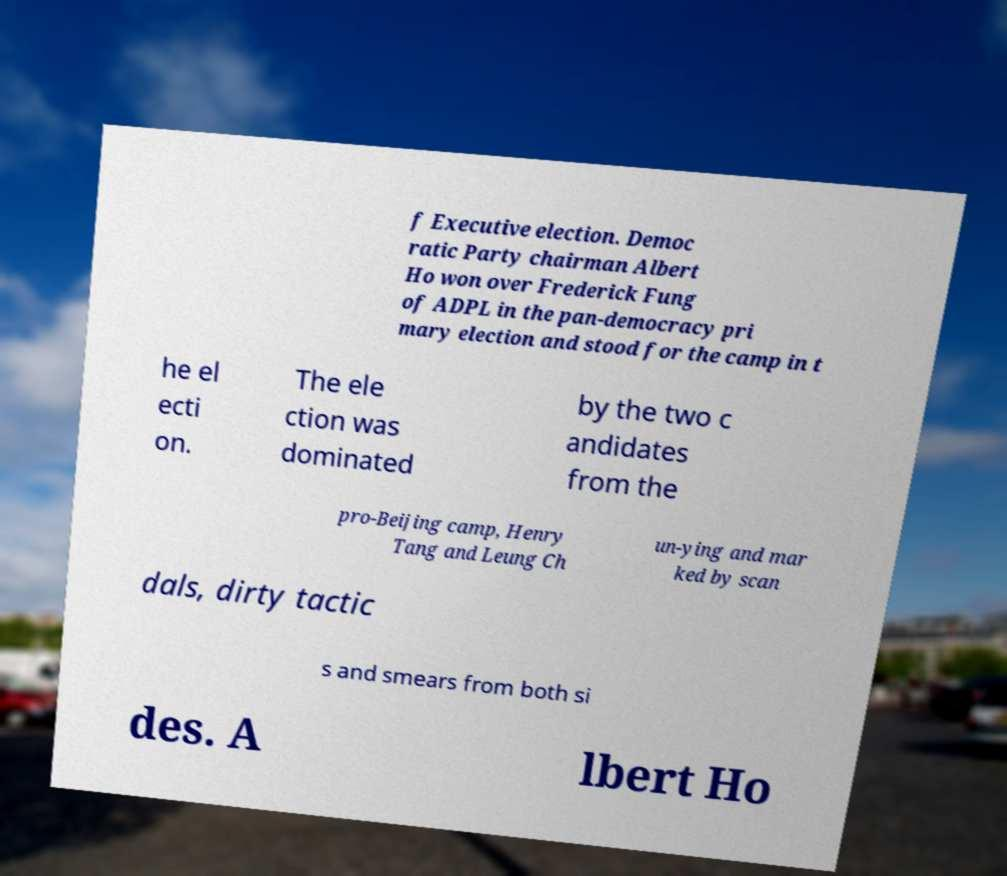Could you extract and type out the text from this image? f Executive election. Democ ratic Party chairman Albert Ho won over Frederick Fung of ADPL in the pan-democracy pri mary election and stood for the camp in t he el ecti on. The ele ction was dominated by the two c andidates from the pro-Beijing camp, Henry Tang and Leung Ch un-ying and mar ked by scan dals, dirty tactic s and smears from both si des. A lbert Ho 